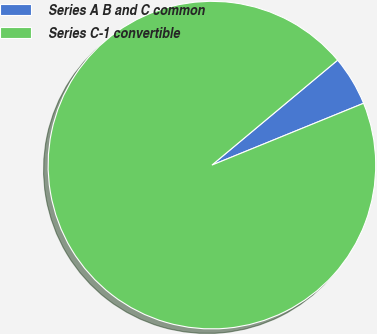Convert chart to OTSL. <chart><loc_0><loc_0><loc_500><loc_500><pie_chart><fcel>Series A B and C common<fcel>Series C-1 convertible<nl><fcel>4.91%<fcel>95.09%<nl></chart> 